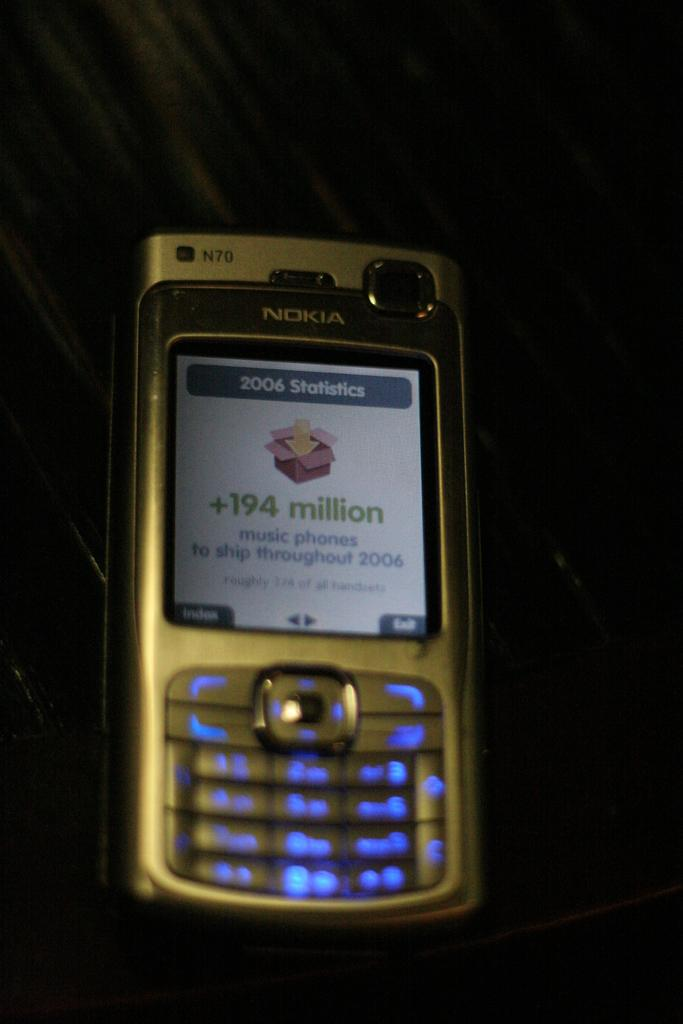<image>
Summarize the visual content of the image. A Nokia phone with a 2006 Statistics screen pulled up. 